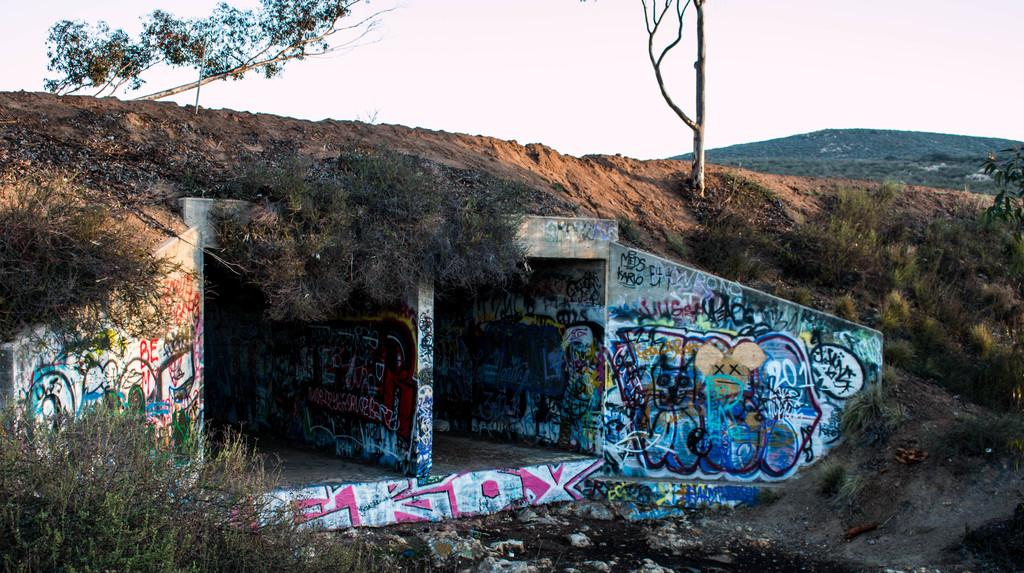<image>
Create a compact narrative representing the image presented. A lot of graffiti around a tunnel with the date 2013 in the middle on the right hand side. 